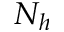<formula> <loc_0><loc_0><loc_500><loc_500>N _ { h }</formula> 